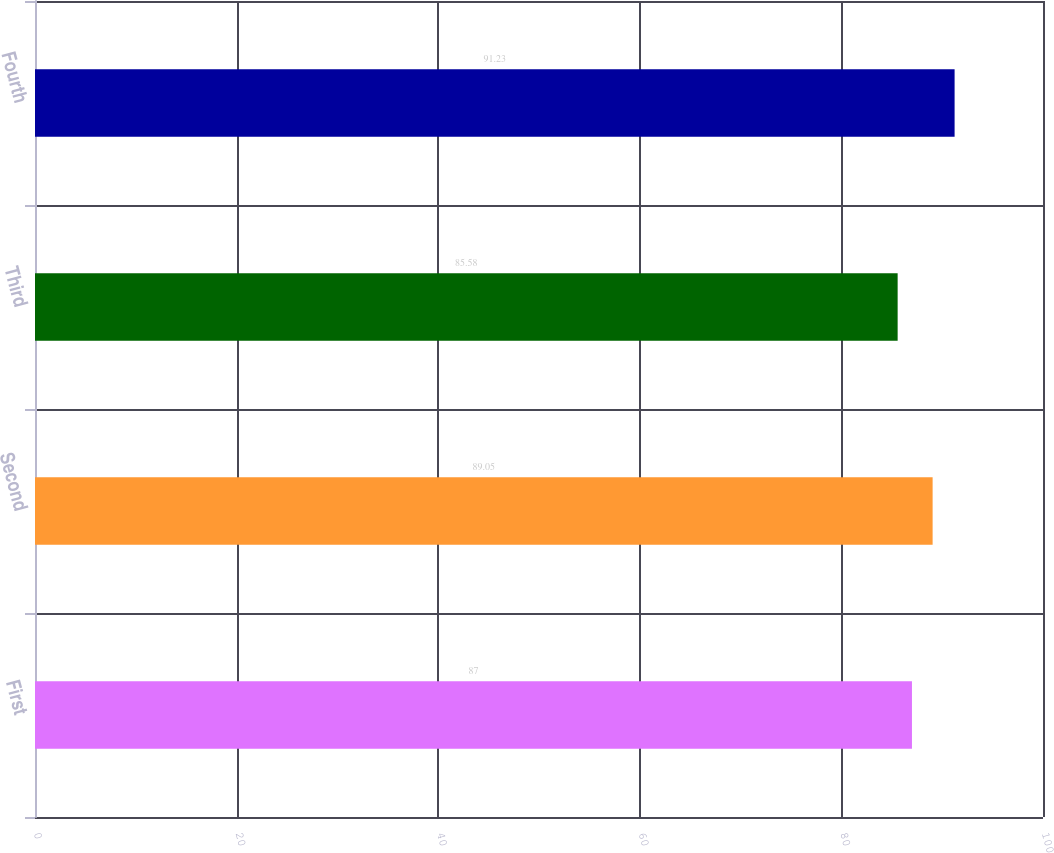Convert chart. <chart><loc_0><loc_0><loc_500><loc_500><bar_chart><fcel>First<fcel>Second<fcel>Third<fcel>Fourth<nl><fcel>87<fcel>89.05<fcel>85.58<fcel>91.23<nl></chart> 